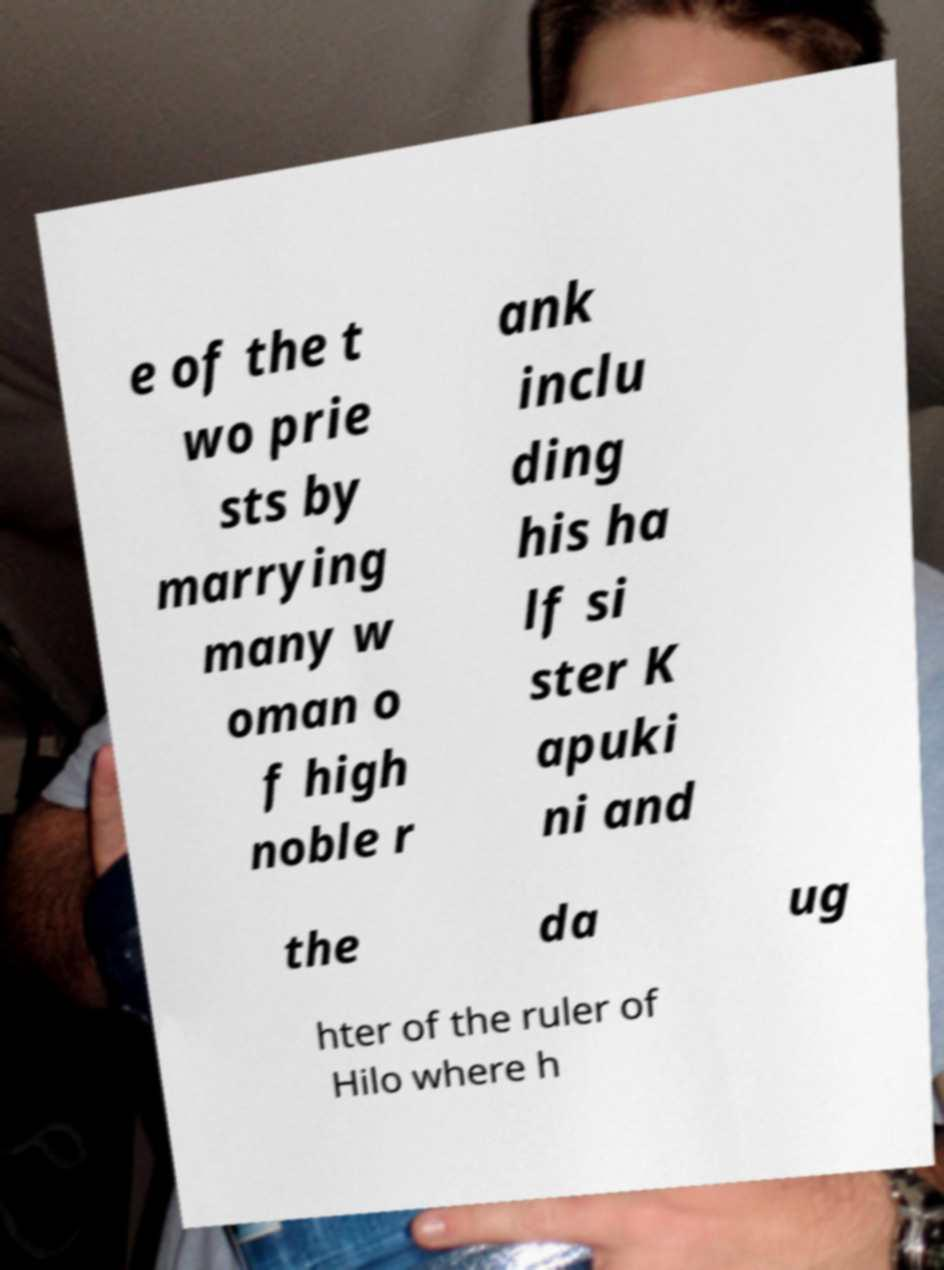I need the written content from this picture converted into text. Can you do that? e of the t wo prie sts by marrying many w oman o f high noble r ank inclu ding his ha lf si ster K apuki ni and the da ug hter of the ruler of Hilo where h 